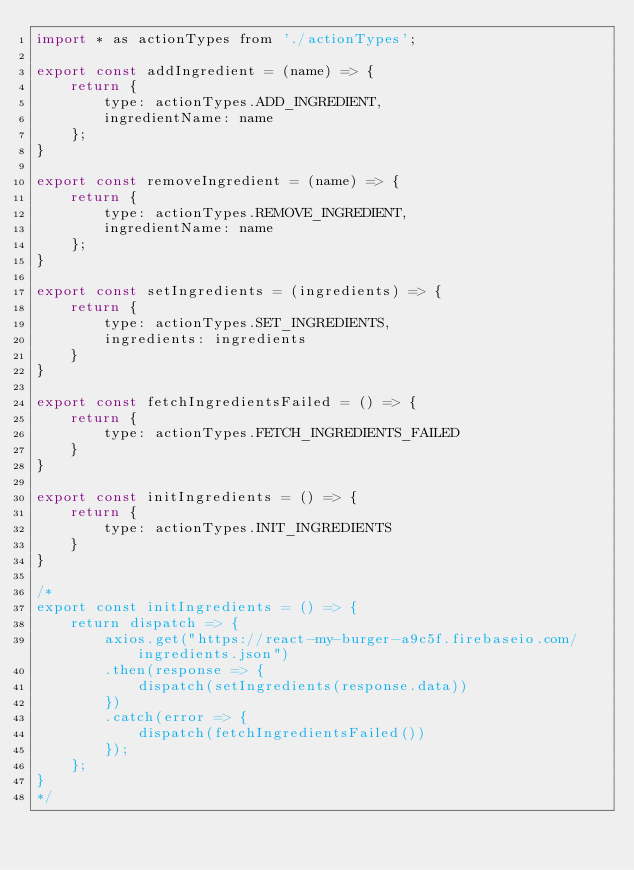<code> <loc_0><loc_0><loc_500><loc_500><_JavaScript_>import * as actionTypes from './actionTypes';

export const addIngredient = (name) => {
    return {
        type: actionTypes.ADD_INGREDIENT,
        ingredientName: name
    };
}

export const removeIngredient = (name) => {
    return {
        type: actionTypes.REMOVE_INGREDIENT,
        ingredientName: name
    };
}

export const setIngredients = (ingredients) => {
    return {
        type: actionTypes.SET_INGREDIENTS,
        ingredients: ingredients
    }
}

export const fetchIngredientsFailed = () => {
    return {
        type: actionTypes.FETCH_INGREDIENTS_FAILED
    }
}

export const initIngredients = () => {
    return {
        type: actionTypes.INIT_INGREDIENTS
    }
}

/*
export const initIngredients = () => {
    return dispatch => {
        axios.get("https://react-my-burger-a9c5f.firebaseio.com/ingredients.json")
        .then(response => {
            dispatch(setIngredients(response.data))
        })
        .catch(error => {
            dispatch(fetchIngredientsFailed())
        });
    };
}
*/</code> 